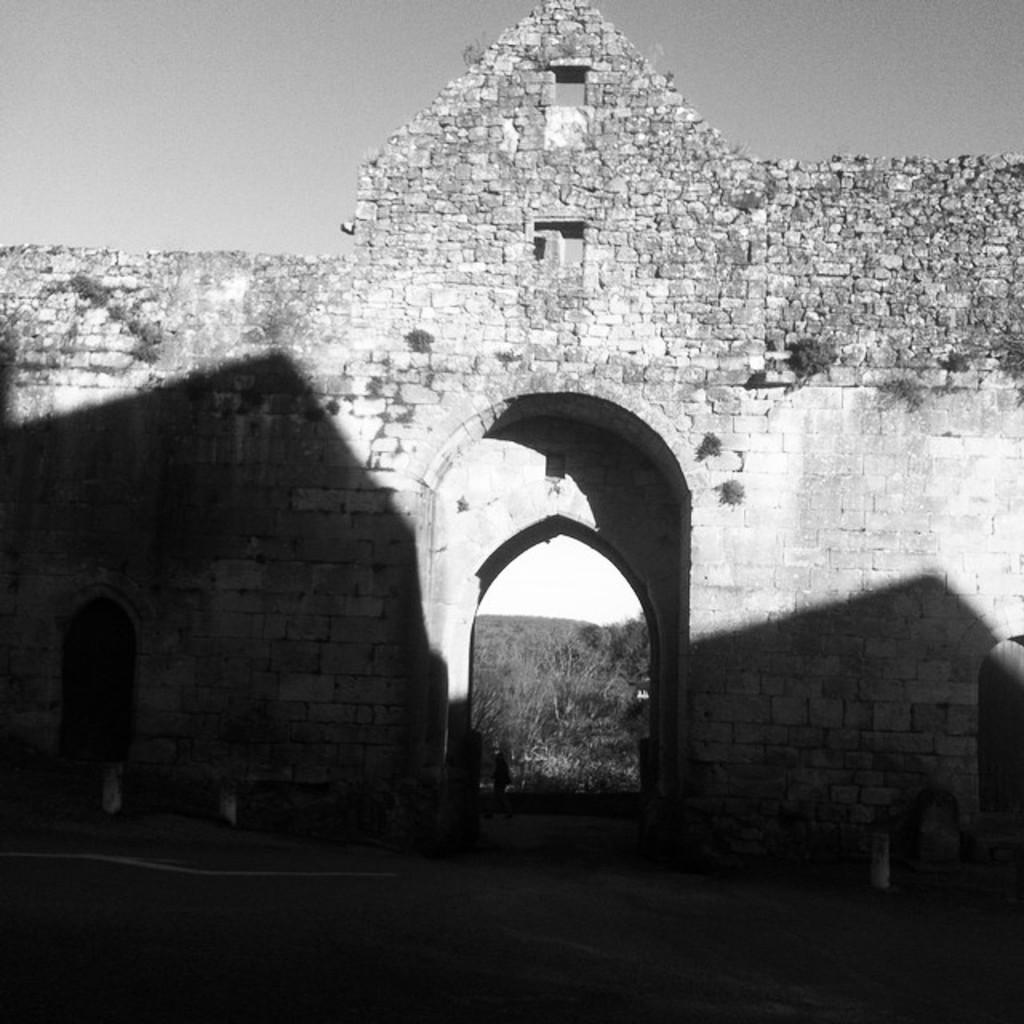How would you summarize this image in a sentence or two? In this picture we can see a wall and few trees, it is a black and white photography. 